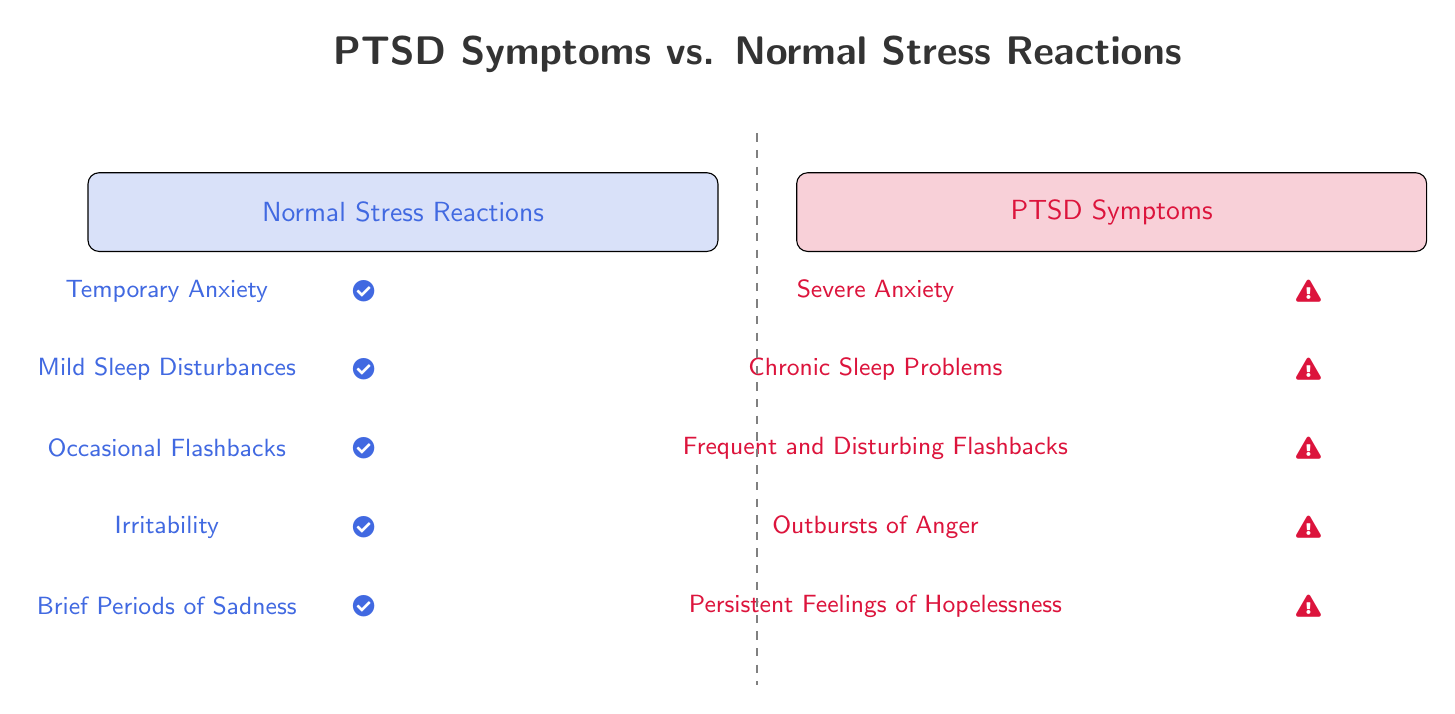What is the color used for Normal Stress Reactions? The diagram uses a light shade of blue (RGB: 65, 105, 225) for Normal Stress Reactions, indicated by the fill color of the corresponding box.
Answer: light blue How many symptoms are listed under PTSD Symptoms? There are five symptoms listed under PTSD Symptoms, as reflected in the count of items in that column.
Answer: 5 What is the fourth symptom listed under Normal Stress Reactions? The fourth symptom for Normal Stress Reactions is Irritability, explicitly stated in the corresponding item in the diagram.
Answer: Irritability Which symptom in the PTSD Symptoms list has a warning sign indicator? The symptom with a warning sign in the PTSD Symptoms list is Frequent and Disturbing Flashbacks, indicated by the icon next to this item.
Answer: Frequent and Disturbing Flashbacks What visual indicator is associated with Normal Stress Reactions? The visual indicator for Normal Stress Reactions is a checkmark, which precedes each item in that section of the diagram.
Answer: checkmark How do Severe Anxiety and Temporary Anxiety differ in terms of visual indicators? Severe Anxiety has a warning sign icon next to it, while Temporary Anxiety has a checkmark, showing a difference in the severity and nature of the symptoms.
Answer: Severe Anxiety has a warning sign; Temporary Anxiety has a checkmark What is the main purpose of the dashed line in the diagram? The dashed line serves as a divider between the sections of Normal Stress Reactions and PTSD Symptoms, visually distinguishing the two sets of symptoms.
Answer: Divide sections How many sections are represented in the diagram? The diagram represents two distinct sections: Normal Stress Reactions and PTSD Symptoms, clearly defined by their separate boxes.
Answer: 2 What is the third symptom listed under PTSD Symptoms? The third symptom listed under PTSD Symptoms is Frequent and Disturbing Flashbacks, under the corresponding heading in the diagram.
Answer: Frequent and Disturbing Flashbacks 